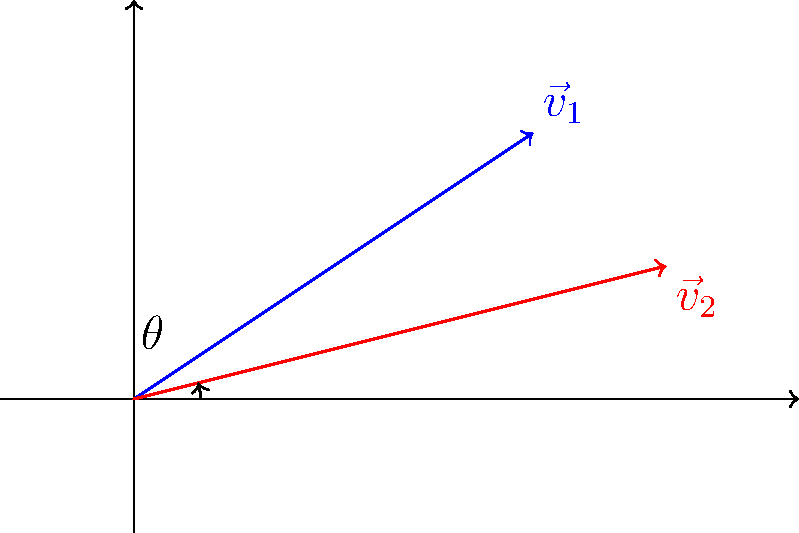In a landmark legal case, two scholars present different interpretations of a crucial text. Their interpretations can be represented as vectors in a 2D space, where the x-axis represents literal interpretation and the y-axis represents contextual interpretation. Scholar A's interpretation is represented by vector $\vec{v}_1 = (3,2)$, while Scholar B's interpretation is represented by vector $\vec{v}_2 = (4,1)$. What is the angle $\theta$ (in degrees, rounded to two decimal places) between these two interpretations? To find the angle between two vectors, we can use the dot product formula:

$$ \cos \theta = \frac{\vec{v}_1 \cdot \vec{v}_2}{|\vec{v}_1||\vec{v}_2|} $$

Step 1: Calculate the dot product $\vec{v}_1 \cdot \vec{v}_2$
$\vec{v}_1 \cdot \vec{v}_2 = (3 \times 4) + (2 \times 1) = 12 + 2 = 14$

Step 2: Calculate the magnitudes of the vectors
$|\vec{v}_1| = \sqrt{3^2 + 2^2} = \sqrt{13}$
$|\vec{v}_2| = \sqrt{4^2 + 1^2} = \sqrt{17}$

Step 3: Apply the dot product formula
$\cos \theta = \frac{14}{\sqrt{13} \times \sqrt{17}}$

Step 4: Calculate $\theta$ using the inverse cosine function
$\theta = \arccos(\frac{14}{\sqrt{13} \times \sqrt{17}})$

Step 5: Convert to degrees and round to two decimal places
$\theta \approx 10.39°$
Answer: 10.39° 